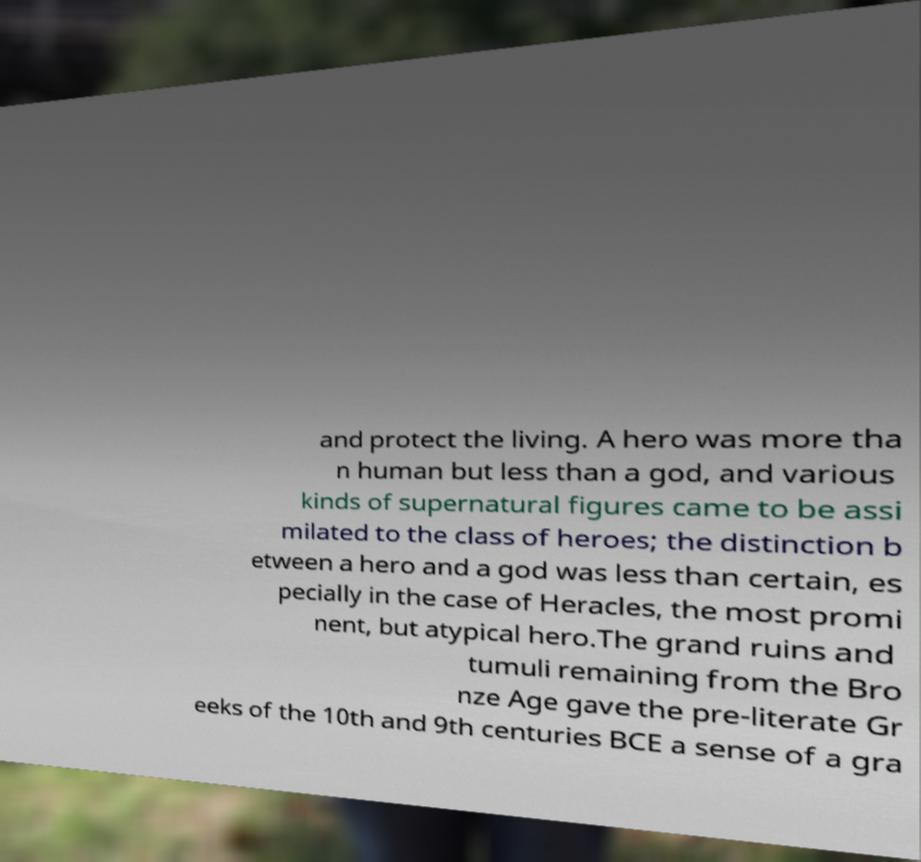Please identify and transcribe the text found in this image. and protect the living. A hero was more tha n human but less than a god, and various kinds of supernatural figures came to be assi milated to the class of heroes; the distinction b etween a hero and a god was less than certain, es pecially in the case of Heracles, the most promi nent, but atypical hero.The grand ruins and tumuli remaining from the Bro nze Age gave the pre-literate Gr eeks of the 10th and 9th centuries BCE a sense of a gra 